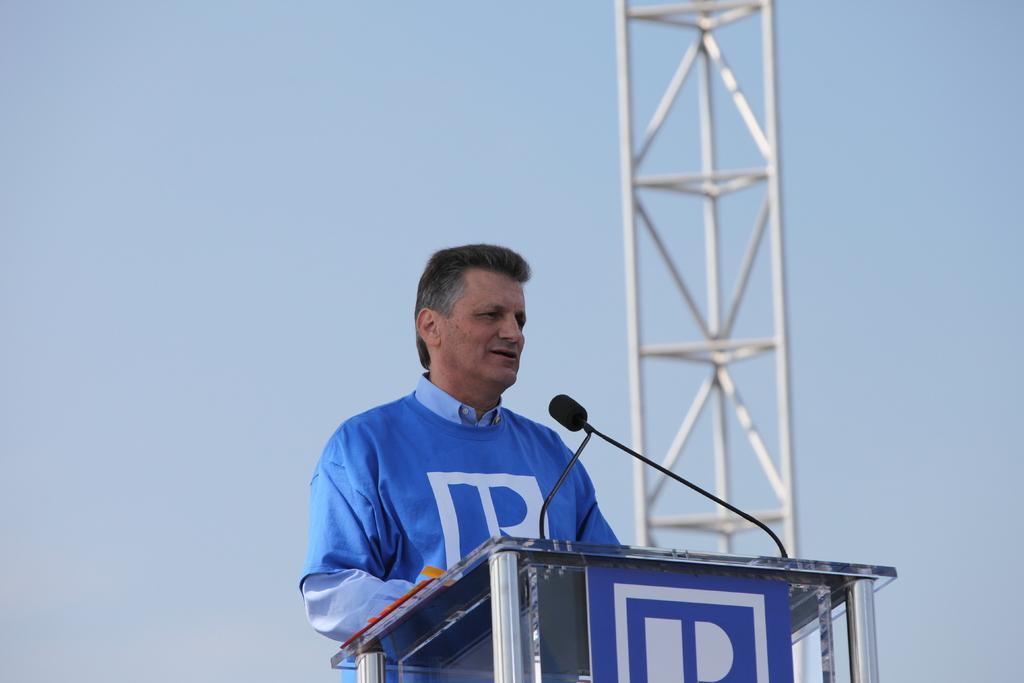In one or two sentences, can you explain what this image depicts? In this picture I can see a podium in front, on which there is a mic and behind the podium I can see a man who is standing. In the background I can see the white color rods on the right side of this picture and I can see the sky. 